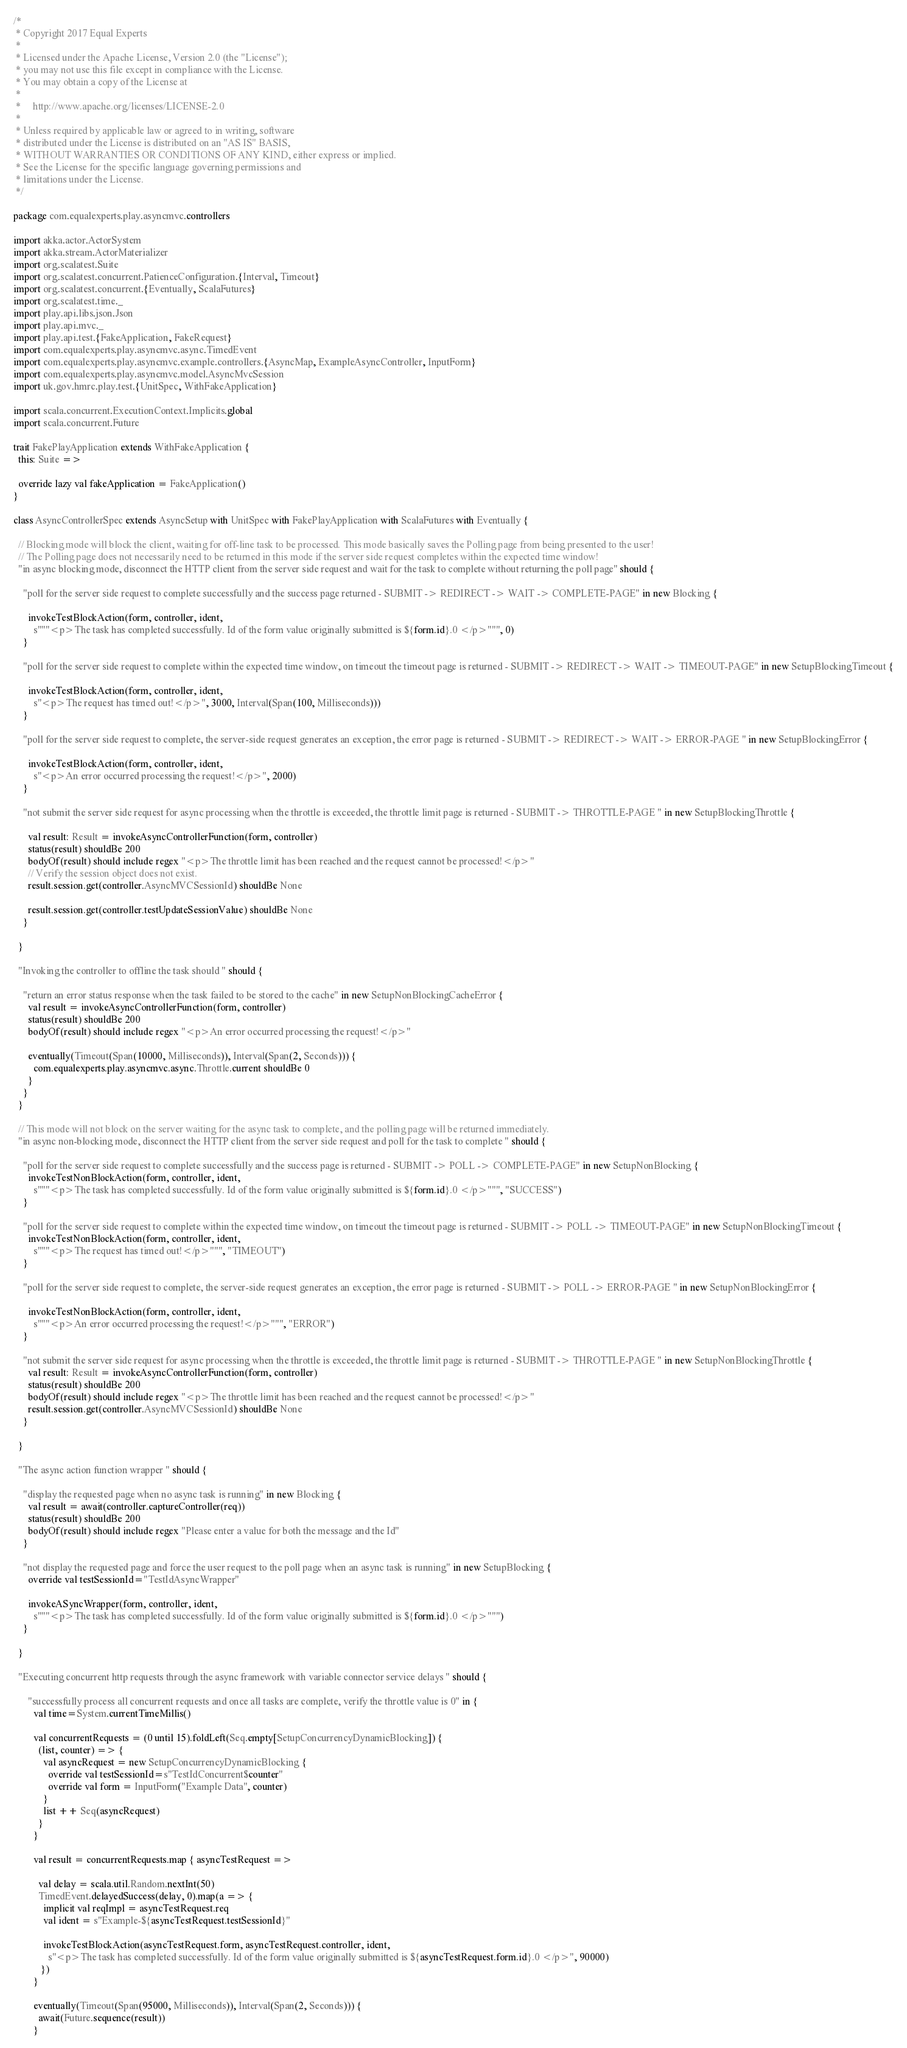<code> <loc_0><loc_0><loc_500><loc_500><_Scala_>/*
 * Copyright 2017 Equal Experts
 *
 * Licensed under the Apache License, Version 2.0 (the "License");
 * you may not use this file except in compliance with the License.
 * You may obtain a copy of the License at
 *
 *     http://www.apache.org/licenses/LICENSE-2.0
 *
 * Unless required by applicable law or agreed to in writing, software
 * distributed under the License is distributed on an "AS IS" BASIS,
 * WITHOUT WARRANTIES OR CONDITIONS OF ANY KIND, either express or implied.
 * See the License for the specific language governing permissions and
 * limitations under the License.
 */

package com.equalexperts.play.asyncmvc.controllers

import akka.actor.ActorSystem
import akka.stream.ActorMaterializer
import org.scalatest.Suite
import org.scalatest.concurrent.PatienceConfiguration.{Interval, Timeout}
import org.scalatest.concurrent.{Eventually, ScalaFutures}
import org.scalatest.time._
import play.api.libs.json.Json
import play.api.mvc._
import play.api.test.{FakeApplication, FakeRequest}
import com.equalexperts.play.asyncmvc.async.TimedEvent
import com.equalexperts.play.asyncmvc.example.controllers.{AsyncMap, ExampleAsyncController, InputForm}
import com.equalexperts.play.asyncmvc.model.AsyncMvcSession
import uk.gov.hmrc.play.test.{UnitSpec, WithFakeApplication}

import scala.concurrent.ExecutionContext.Implicits.global
import scala.concurrent.Future

trait FakePlayApplication extends WithFakeApplication {
  this: Suite =>

  override lazy val fakeApplication = FakeApplication()
}

class AsyncControllerSpec extends AsyncSetup with UnitSpec with FakePlayApplication with ScalaFutures with Eventually {

  // Blocking mode will block the client, waiting for off-line task to be processed. This mode basically saves the Polling page from being presented to the user!
  // The Polling page does not necessarily need to be returned in this mode if the server side request completes within the expected time window!
  "in async blocking mode, disconnect the HTTP client from the server side request and wait for the task to complete without returning the poll page" should {

    "poll for the server side request to complete successfully and the success page returned - SUBMIT -> REDIRECT -> WAIT -> COMPLETE-PAGE" in new Blocking {

      invokeTestBlockAction(form, controller, ident,
        s"""<p>The task has completed successfully. Id of the form value originally submitted is ${form.id}.0 </p>""", 0)
    }

    "poll for the server side request to complete within the expected time window, on timeout the timeout page is returned - SUBMIT -> REDIRECT -> WAIT -> TIMEOUT-PAGE" in new SetupBlockingTimeout {

      invokeTestBlockAction(form, controller, ident,
        s"<p>The request has timed out!</p>", 3000, Interval(Span(100, Milliseconds)))
    }

    "poll for the server side request to complete, the server-side request generates an exception, the error page is returned - SUBMIT -> REDIRECT -> WAIT -> ERROR-PAGE " in new SetupBlockingError {

      invokeTestBlockAction(form, controller, ident,
        s"<p>An error occurred processing the request!</p>", 2000)
    }

    "not submit the server side request for async processing when the throttle is exceeded, the throttle limit page is returned - SUBMIT -> THROTTLE-PAGE " in new SetupBlockingThrottle {

      val result: Result = invokeAsyncControllerFunction(form, controller)
      status(result) shouldBe 200
      bodyOf(result) should include regex "<p>The throttle limit has been reached and the request cannot be processed!</p>"
      // Verify the session object does not exist.
      result.session.get(controller.AsyncMVCSessionId) shouldBe None

      result.session.get(controller.testUpdateSessionValue) shouldBe None
    }

  }

  "Invoking the controller to offline the task should " should {

    "return an error status response when the task failed to be stored to the cache" in new SetupNonBlockingCacheError {
      val result = invokeAsyncControllerFunction(form, controller)
      status(result) shouldBe 200
      bodyOf(result) should include regex "<p>An error occurred processing the request!</p>"

      eventually(Timeout(Span(10000, Milliseconds)), Interval(Span(2, Seconds))) {
        com.equalexperts.play.asyncmvc.async.Throttle.current shouldBe 0
      }
    }
  }

  // This mode will not block on the server waiting for the async task to complete, and the polling page will be returned immediately.
  "in async non-blocking mode, disconnect the HTTP client from the server side request and poll for the task to complete " should {

    "poll for the server side request to complete successfully and the success page is returned - SUBMIT -> POLL -> COMPLETE-PAGE" in new SetupNonBlocking {
      invokeTestNonBlockAction(form, controller, ident,
        s"""<p>The task has completed successfully. Id of the form value originally submitted is ${form.id}.0 </p>""", "SUCCESS")
    }

    "poll for the server side request to complete within the expected time window, on timeout the timeout page is returned - SUBMIT -> POLL -> TIMEOUT-PAGE" in new SetupNonBlockingTimeout {
      invokeTestNonBlockAction(form, controller, ident,
        s"""<p>The request has timed out!</p>""", "TIMEOUT")
    }

    "poll for the server side request to complete, the server-side request generates an exception, the error page is returned - SUBMIT -> POLL -> ERROR-PAGE " in new SetupNonBlockingError {

      invokeTestNonBlockAction(form, controller, ident,
        s"""<p>An error occurred processing the request!</p>""", "ERROR")
    }

    "not submit the server side request for async processing when the throttle is exceeded, the throttle limit page is returned - SUBMIT -> THROTTLE-PAGE " in new SetupNonBlockingThrottle {
      val result: Result = invokeAsyncControllerFunction(form, controller)
      status(result) shouldBe 200
      bodyOf(result) should include regex "<p>The throttle limit has been reached and the request cannot be processed!</p>"
      result.session.get(controller.AsyncMVCSessionId) shouldBe None
    }

  }

  "The async action function wrapper " should {

    "display the requested page when no async task is running" in new Blocking {
      val result = await(controller.captureController(req))
      status(result) shouldBe 200
      bodyOf(result) should include regex "Please enter a value for both the message and the Id"
    }

    "not display the requested page and force the user request to the poll page when an async task is running" in new SetupBlocking {
      override val testSessionId="TestIdAsyncWrapper"

      invokeASyncWrapper(form, controller, ident,
        s"""<p>The task has completed successfully. Id of the form value originally submitted is ${form.id}.0 </p>""")
    }

  }

  "Executing concurrent http requests through the async framework with variable connector service delays " should {

      "successfully process all concurrent requests and once all tasks are complete, verify the throttle value is 0" in {
        val time=System.currentTimeMillis()

        val concurrentRequests = (0 until 15).foldLeft(Seq.empty[SetupConcurrencyDynamicBlocking]) {
          (list, counter) => {
            val asyncRequest = new SetupConcurrencyDynamicBlocking {
              override val testSessionId=s"TestIdConcurrent$counter"
              override val form = InputForm("Example Data", counter)
            }
            list ++ Seq(asyncRequest)
          }
        }

        val result = concurrentRequests.map { asyncTestRequest =>

          val delay = scala.util.Random.nextInt(50)
          TimedEvent.delayedSuccess(delay, 0).map(a => {
            implicit val reqImpl = asyncTestRequest.req
            val ident = s"Example-${asyncTestRequest.testSessionId}"

            invokeTestBlockAction(asyncTestRequest.form, asyncTestRequest.controller, ident,
              s"<p>The task has completed successfully. Id of the form value originally submitted is ${asyncTestRequest.form.id}.0 </p>", 90000)
           })
        }

        eventually(Timeout(Span(95000, Milliseconds)), Interval(Span(2, Seconds))) {
          await(Future.sequence(result))
        }
</code> 